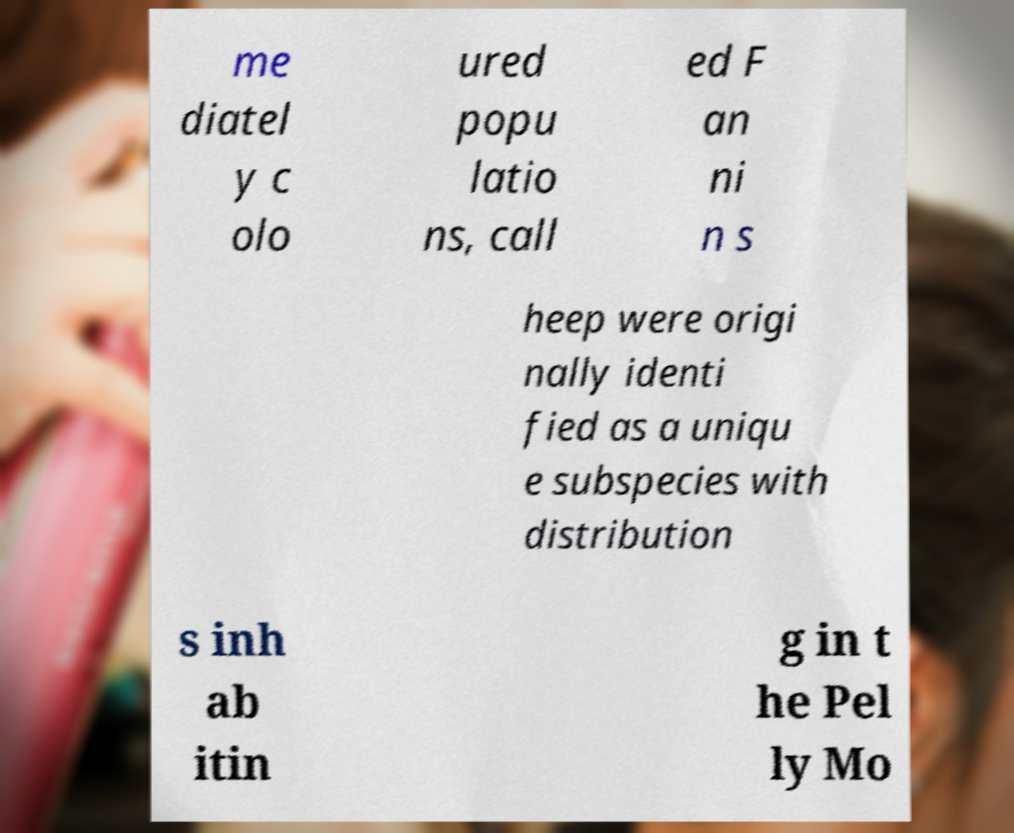Please read and relay the text visible in this image. What does it say? me diatel y c olo ured popu latio ns, call ed F an ni n s heep were origi nally identi fied as a uniqu e subspecies with distribution s inh ab itin g in t he Pel ly Mo 